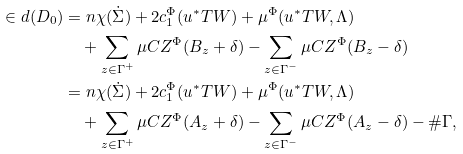Convert formula to latex. <formula><loc_0><loc_0><loc_500><loc_500>\in d ( D _ { 0 } ) & = n \chi ( \dot { \Sigma } ) + 2 c _ { 1 } ^ { \Phi } ( u ^ { * } T W ) + \mu ^ { \Phi } ( u ^ { * } T W , \Lambda ) \\ & \quad + \sum _ { z \in \Gamma ^ { + } } \mu C Z ^ { \Phi } ( B _ { z } + \delta ) - \sum _ { z \in \Gamma ^ { - } } \mu C Z ^ { \Phi } ( B _ { z } - \delta ) \\ & = n \chi ( \dot { \Sigma } ) + 2 c _ { 1 } ^ { \Phi } ( u ^ { * } T W ) + \mu ^ { \Phi } ( u ^ { * } T W , \Lambda ) \\ & \quad + \sum _ { z \in \Gamma ^ { + } } \mu C Z ^ { \Phi } ( A _ { z } + \delta ) - \sum _ { z \in \Gamma ^ { - } } \mu C Z ^ { \Phi } ( A _ { z } - \delta ) - \# \Gamma ,</formula> 